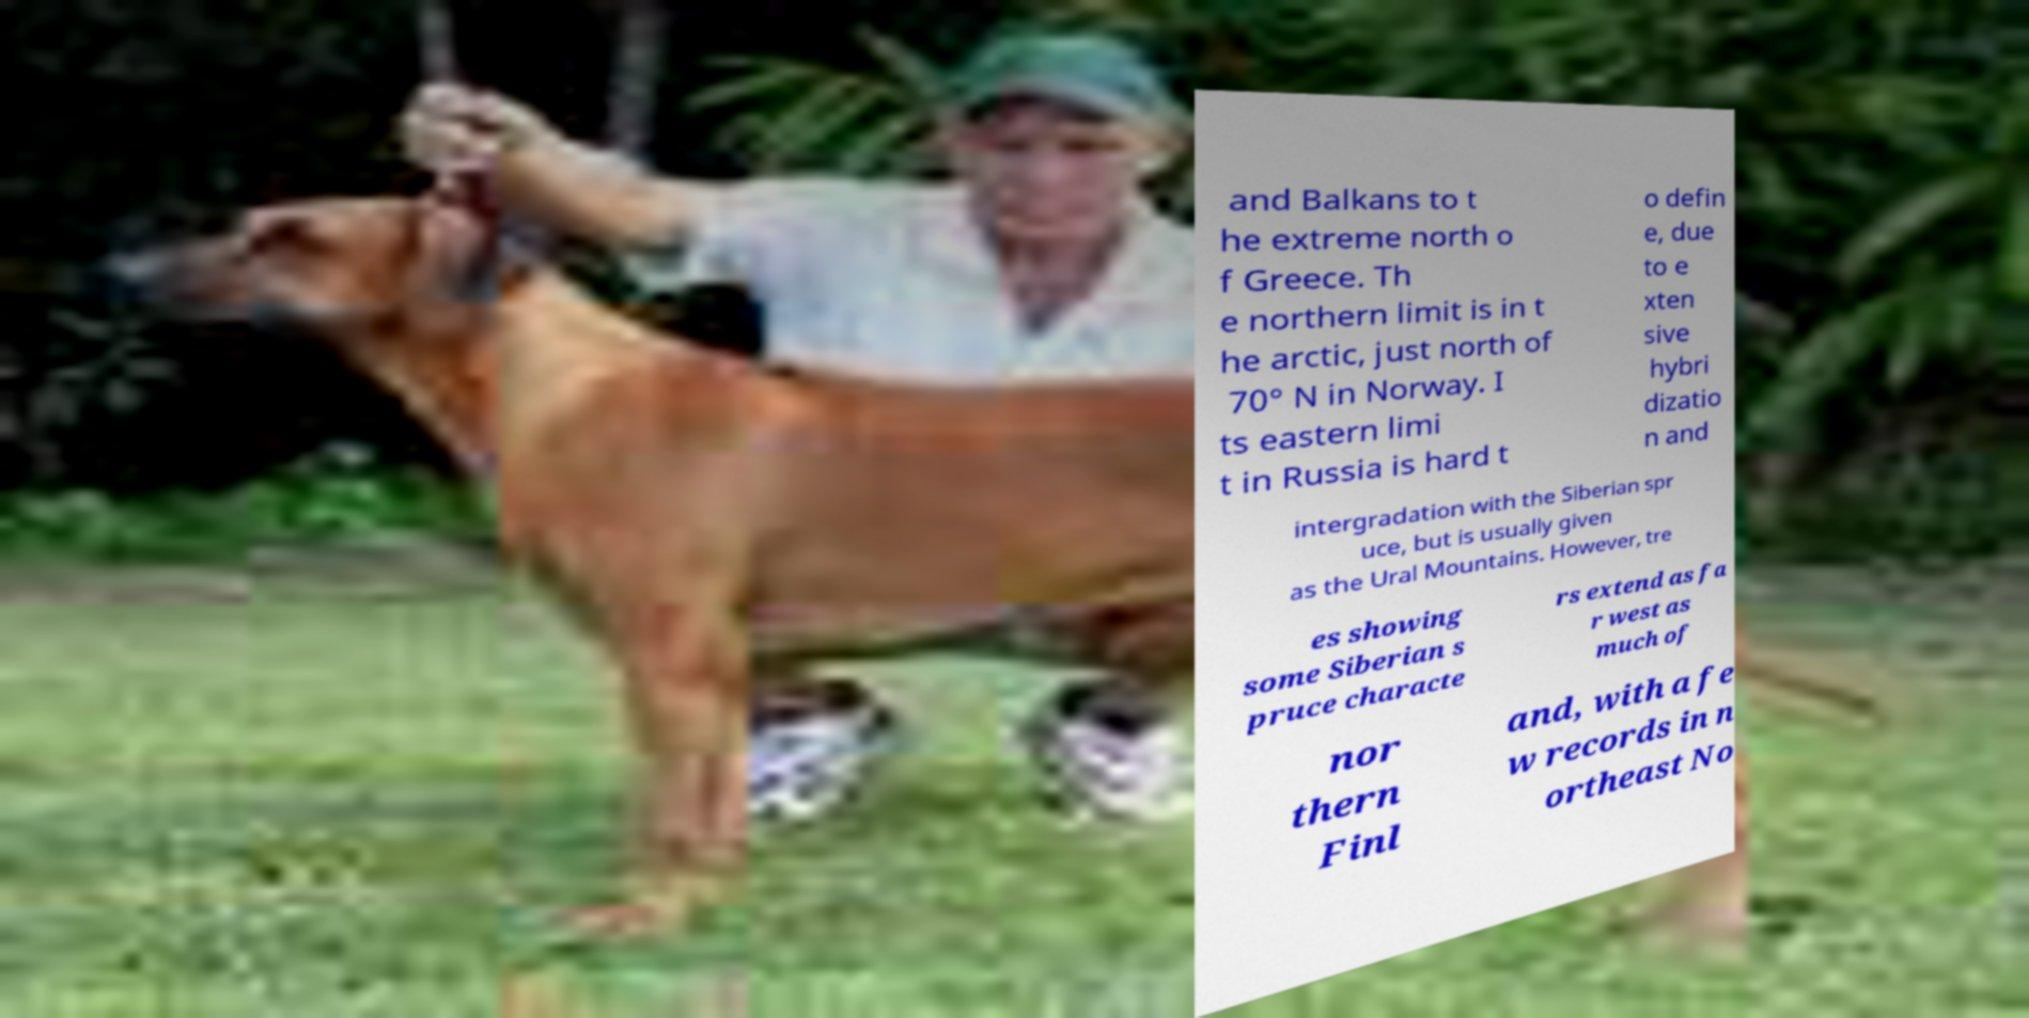There's text embedded in this image that I need extracted. Can you transcribe it verbatim? and Balkans to t he extreme north o f Greece. Th e northern limit is in t he arctic, just north of 70° N in Norway. I ts eastern limi t in Russia is hard t o defin e, due to e xten sive hybri dizatio n and intergradation with the Siberian spr uce, but is usually given as the Ural Mountains. However, tre es showing some Siberian s pruce characte rs extend as fa r west as much of nor thern Finl and, with a fe w records in n ortheast No 